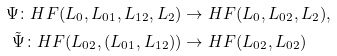Convert formula to latex. <formula><loc_0><loc_0><loc_500><loc_500>\Psi \colon H F ( L _ { 0 } , L _ { 0 1 } , L _ { 1 2 } , L _ { 2 } ) & \to H F ( L _ { 0 } , L _ { 0 2 } , L _ { 2 } ) , \\ \tilde { \Psi } \colon H F ( L _ { 0 2 } , ( L _ { 0 1 } , L _ { 1 2 } ) ) & \to H F ( L _ { 0 2 } , L _ { 0 2 } )</formula> 